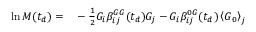Convert formula to latex. <formula><loc_0><loc_0><loc_500><loc_500>\begin{array} { r l } { \ln M ( t _ { d } ) = } & - \frac { 1 } { 2 } G _ { i } \beta _ { i j } ^ { G G } ( t _ { d } ) G _ { j } - G _ { i } \beta _ { i j } ^ { 0 G } ( t _ { d } ) \left \langle G _ { 0 } \right \rangle _ { j } } \end{array}</formula> 